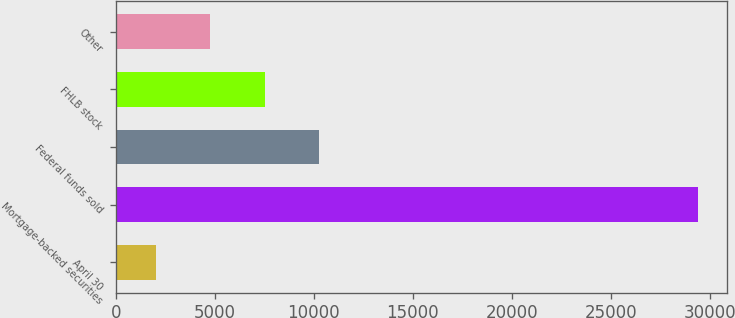Convert chart to OTSL. <chart><loc_0><loc_0><loc_500><loc_500><bar_chart><fcel>April 30<fcel>Mortgage-backed securities<fcel>Federal funds sold<fcel>FHLB stock<fcel>Other<nl><fcel>2008<fcel>29401<fcel>10275.3<fcel>7536<fcel>4747.3<nl></chart> 